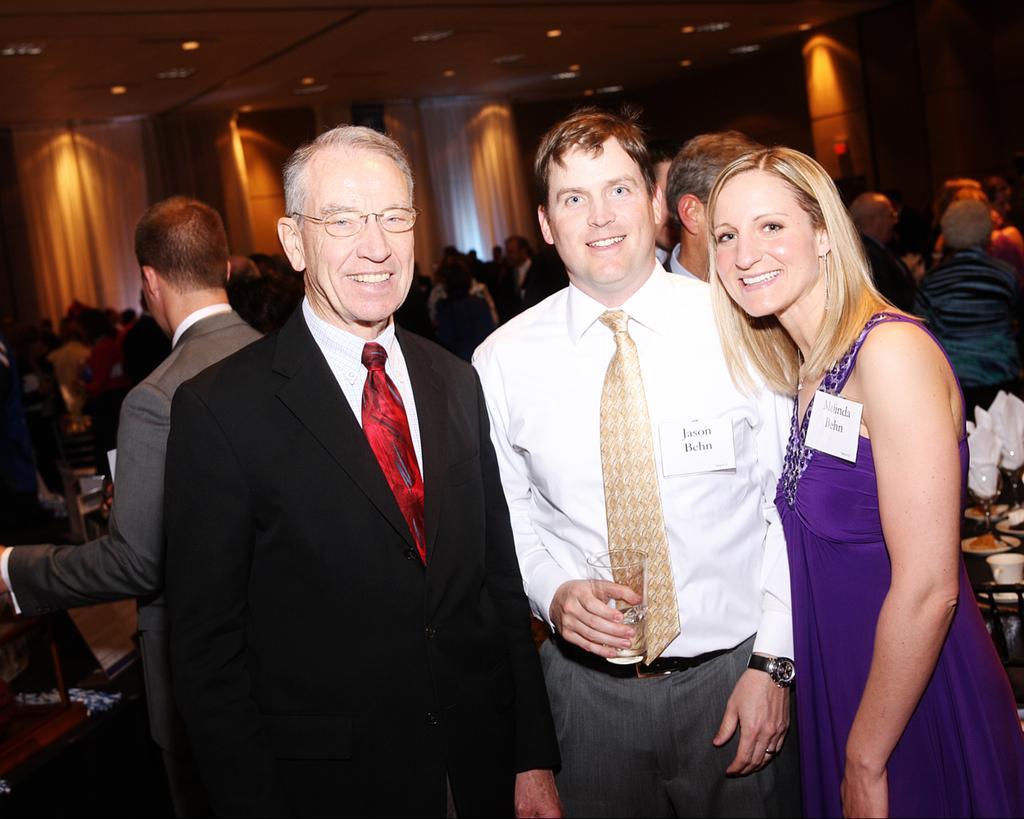How would you summarize this image in a sentence or two? In this image we can see a woman and two men are smiling and one of them is holding a glass. In the background we can see people, glasses, tissue papers, cup, curtains, ceiling, lights, and other objects. 